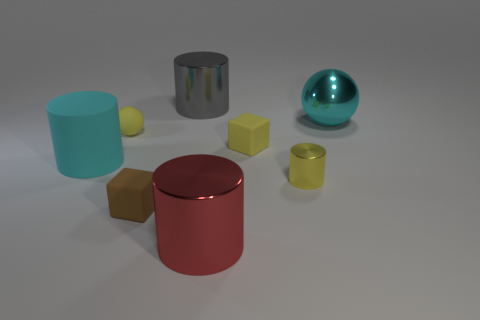How many large matte cylinders are the same color as the big shiny ball?
Give a very brief answer. 1. What number of red cylinders are the same material as the yellow cube?
Your answer should be compact. 0. What number of objects are big cyan rubber things or cylinders that are in front of the cyan shiny sphere?
Keep it short and to the point. 3. Is the material of the cylinder that is on the left side of the gray cylinder the same as the tiny brown thing?
Your response must be concise. Yes. The sphere that is the same size as the cyan rubber cylinder is what color?
Offer a terse response. Cyan. Are there any tiny yellow things of the same shape as the tiny brown rubber object?
Your answer should be very brief. Yes. What is the color of the big cylinder that is to the left of the ball that is on the left side of the big cylinder that is in front of the small cylinder?
Offer a terse response. Cyan. What number of matte things are tiny yellow objects or tiny blocks?
Provide a succinct answer. 3. Is the number of large matte cylinders to the left of the large red shiny thing greater than the number of tiny rubber objects that are on the right side of the yellow block?
Offer a very short reply. Yes. What number of other things are the same size as the brown matte block?
Ensure brevity in your answer.  3. 